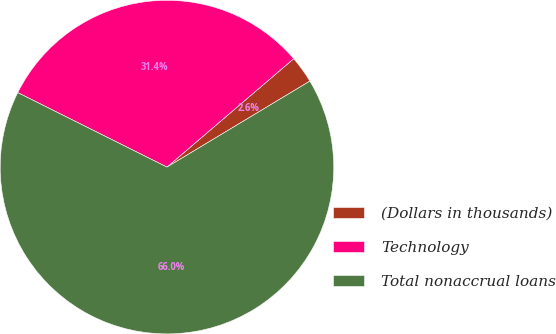Convert chart. <chart><loc_0><loc_0><loc_500><loc_500><pie_chart><fcel>(Dollars in thousands)<fcel>Technology<fcel>Total nonaccrual loans<nl><fcel>2.64%<fcel>31.37%<fcel>65.99%<nl></chart> 